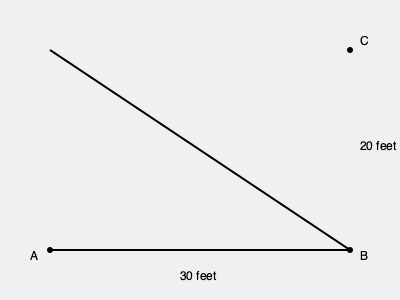As part of a construction project to improve accessibility, you need to build a wheelchair ramp. The ramp needs to extend 30 feet horizontally and rise 20 feet vertically to reach the entrance. What is the slope of this ramp? To find the slope of the ramp, we need to follow these steps:

1) Recall the slope formula: 
   $\text{Slope} = \frac{\text{Rise}}{\text{Run}}$

2) Identify the rise and run from the diagram:
   Rise = 20 feet (vertical distance)
   Run = 30 feet (horizontal distance)

3) Plug these values into the slope formula:
   $\text{Slope} = \frac{20 \text{ feet}}{30 \text{ feet}}$

4) Simplify the fraction:
   $\text{Slope} = \frac{2}{3}$

5) To express as a percentage, multiply by 100:
   $\text{Slope} = \frac{2}{3} \times 100 = 66.67\%$

Therefore, the slope of the ramp is $\frac{2}{3}$ or approximately 66.67%.

Note: In construction, slopes are often expressed as a ratio. In this case, it would be a 2:3 slope or a "rise over run" of 2/3.
Answer: $\frac{2}{3}$ or 66.67% 